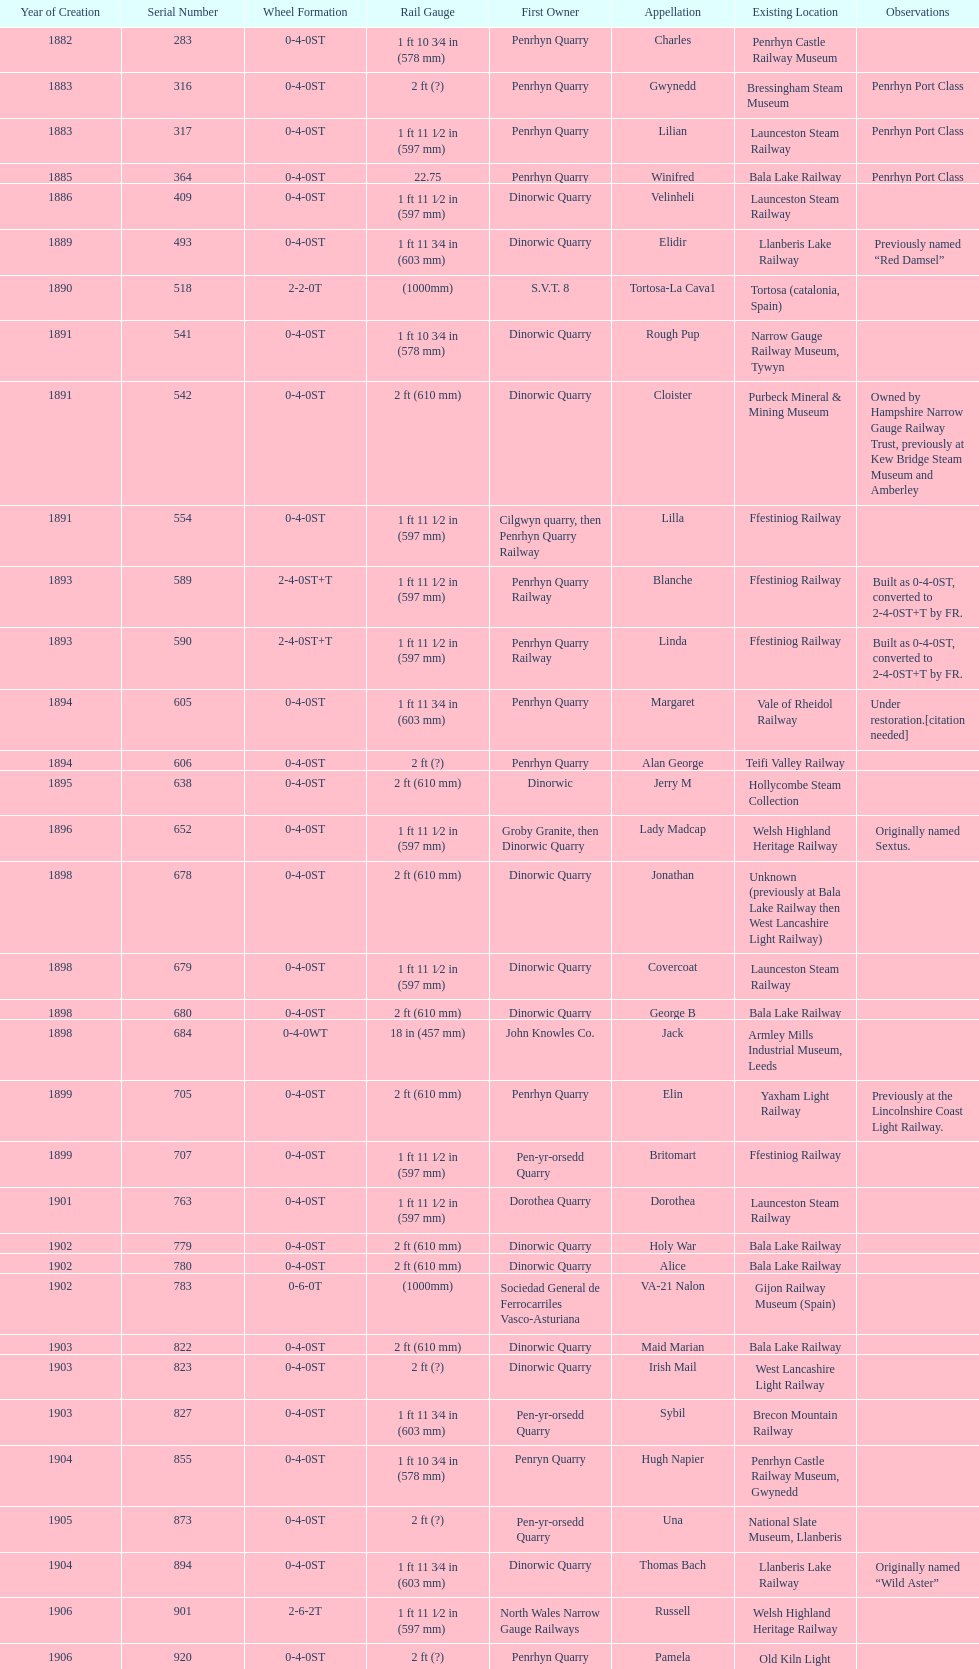Which original owner had the most locomotives? Penrhyn Quarry. 